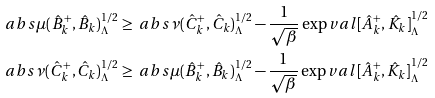<formula> <loc_0><loc_0><loc_500><loc_500>\ a b s { \mu } ( \hat { B } _ { k } ^ { + } , \hat { B } _ { k } ) _ { \Lambda } ^ { 1 / 2 } & \geq \ a b s { \nu } ( \hat { C } _ { k } ^ { + } , \hat { C } _ { k } ) _ { \Lambda } ^ { 1 / 2 } - \frac { 1 } { \sqrt { \beta } } \exp v a l { [ \hat { A } _ { k } ^ { + } , \hat { K } _ { k } ] } _ { \Lambda } ^ { 1 / 2 } \\ \ a b s { \nu } ( \hat { C } _ { k } ^ { + } , \hat { C } _ { k } ) _ { \Lambda } ^ { 1 / 2 } & \geq \ a b s { \mu } ( \hat { B } _ { k } ^ { + } , \hat { B } _ { k } ) _ { \Lambda } ^ { 1 / 2 } - \frac { 1 } { \sqrt { \beta } } \exp v a l { [ \hat { A } _ { k } ^ { + } , \hat { K } _ { k } ] } _ { \Lambda } ^ { 1 / 2 }</formula> 